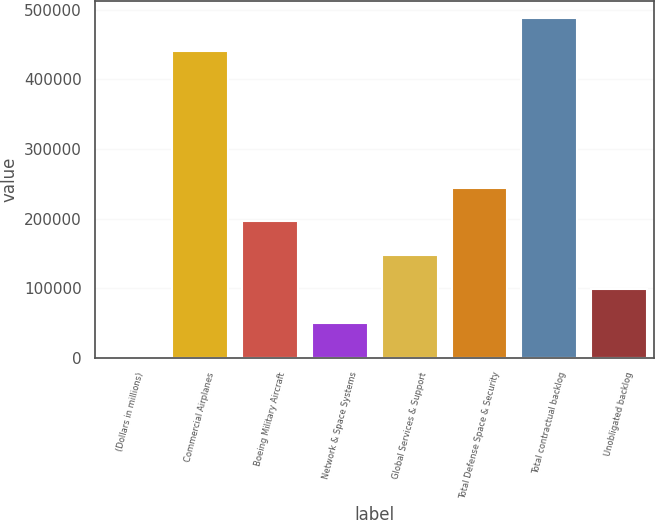<chart> <loc_0><loc_0><loc_500><loc_500><bar_chart><fcel>(Dollars in millions)<fcel>Commercial Airplanes<fcel>Boeing Military Aircraft<fcel>Network & Space Systems<fcel>Global Services & Support<fcel>Total Defense Space & Security<fcel>Total contractual backlog<fcel>Unobligated backlog<nl><fcel>2014<fcel>440118<fcel>196045<fcel>50521.8<fcel>147537<fcel>244553<fcel>488626<fcel>99029.6<nl></chart> 